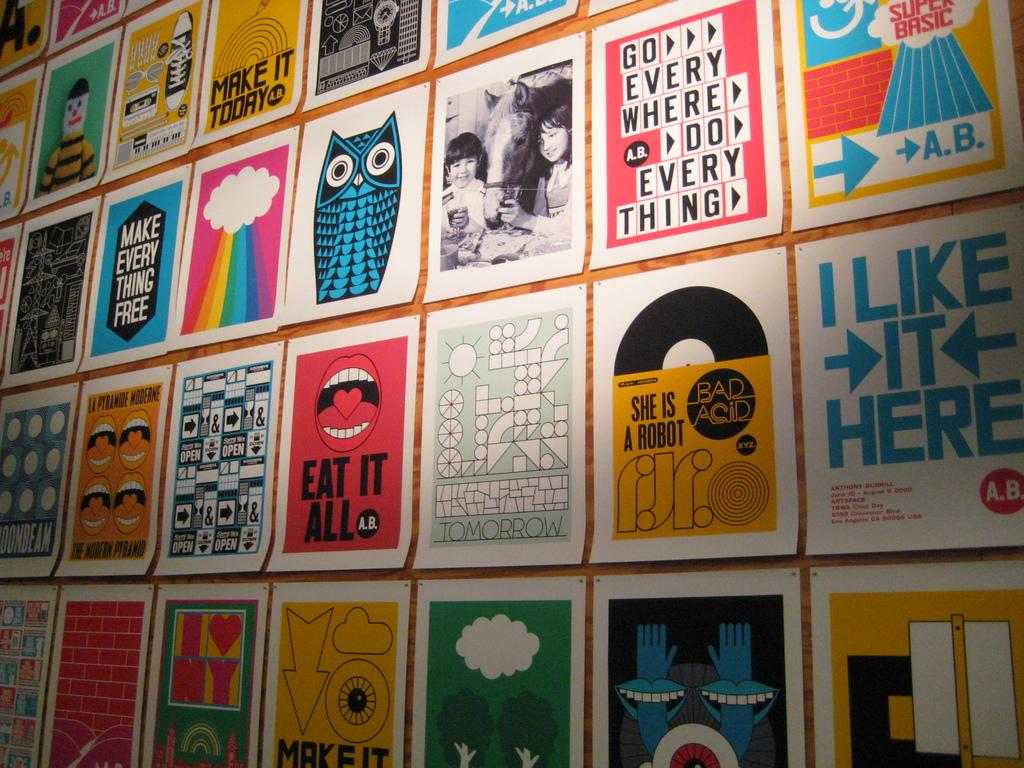<image>
Offer a succinct explanation of the picture presented. A bunch of posters are lined up together, including an owl and a mouth that says "EAT IT ALL". 